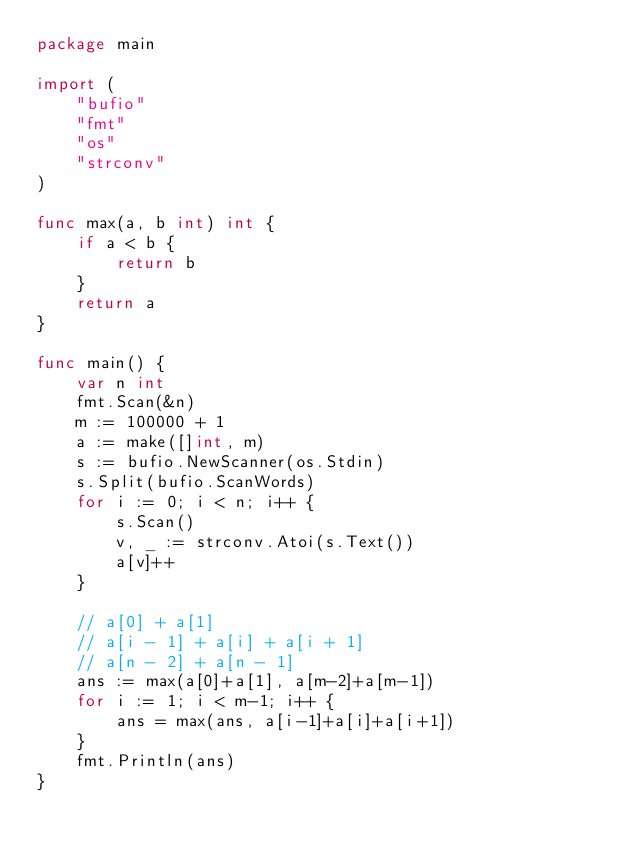<code> <loc_0><loc_0><loc_500><loc_500><_Go_>package main

import (
	"bufio"
	"fmt"
	"os"
	"strconv"
)

func max(a, b int) int {
	if a < b {
		return b
	}
	return a
}

func main() {
	var n int
	fmt.Scan(&n)
	m := 100000 + 1
	a := make([]int, m)
	s := bufio.NewScanner(os.Stdin)
	s.Split(bufio.ScanWords)
	for i := 0; i < n; i++ {
		s.Scan()
		v, _ := strconv.Atoi(s.Text())
		a[v]++
	}

	// a[0] + a[1]
	// a[i - 1] + a[i] + a[i + 1]
	// a[n - 2] + a[n - 1]
	ans := max(a[0]+a[1], a[m-2]+a[m-1])
	for i := 1; i < m-1; i++ {
		ans = max(ans, a[i-1]+a[i]+a[i+1])
	}
	fmt.Println(ans)
}
</code> 